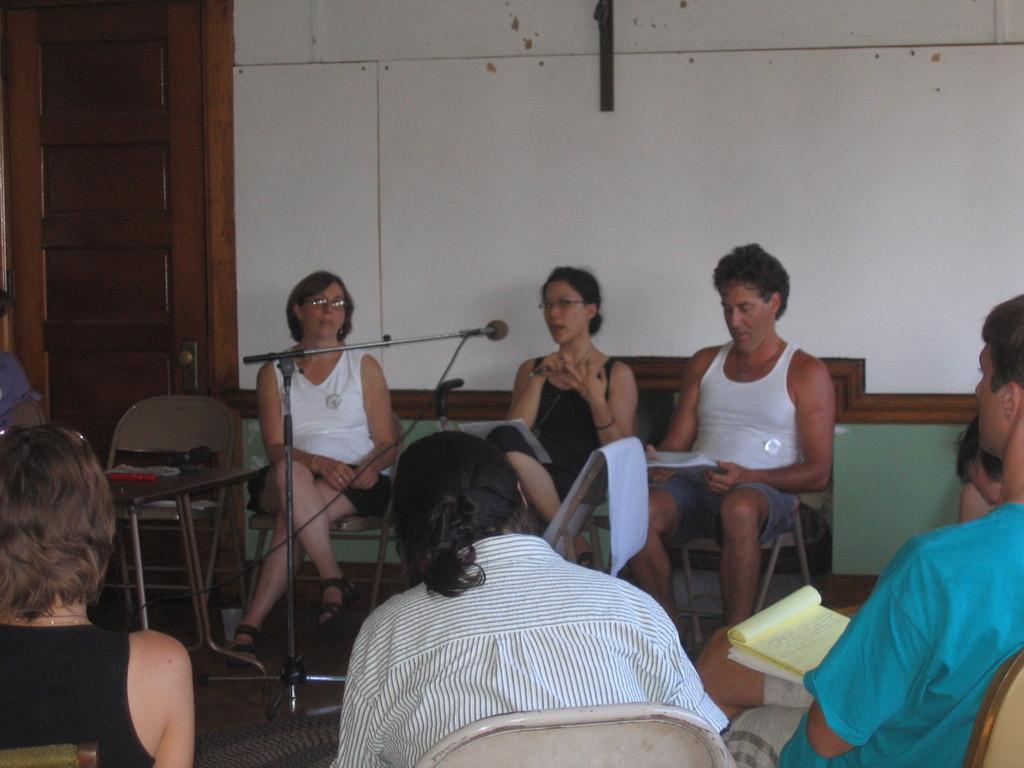Please provide a concise description of this image. The picture is taken in a room. In the foreground of the picture there are people sitting in chairs. Many are holding notebooks. In the center of the picture there is a mic. On the left there is a table and chair. At the top left there is a door. At the top it is wall painted white. 